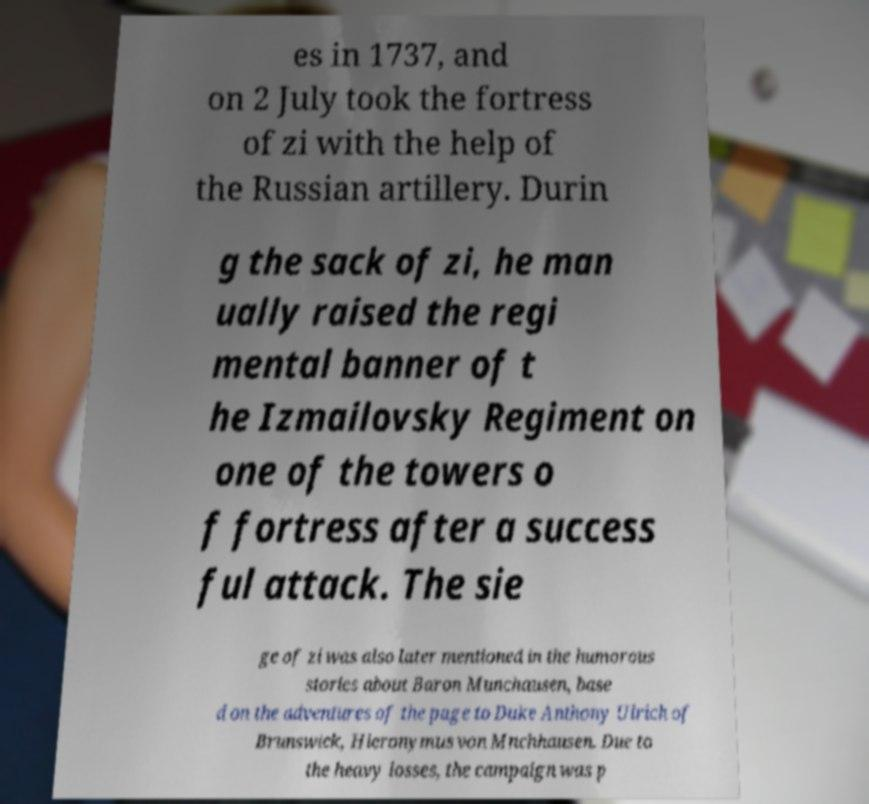Please read and relay the text visible in this image. What does it say? es in 1737, and on 2 July took the fortress of zi with the help of the Russian artillery. Durin g the sack of zi, he man ually raised the regi mental banner of t he Izmailovsky Regiment on one of the towers o f fortress after a success ful attack. The sie ge of zi was also later mentioned in the humorous stories about Baron Munchausen, base d on the adventures of the page to Duke Anthony Ulrich of Brunswick, Hieronymus von Mnchhausen. Due to the heavy losses, the campaign was p 